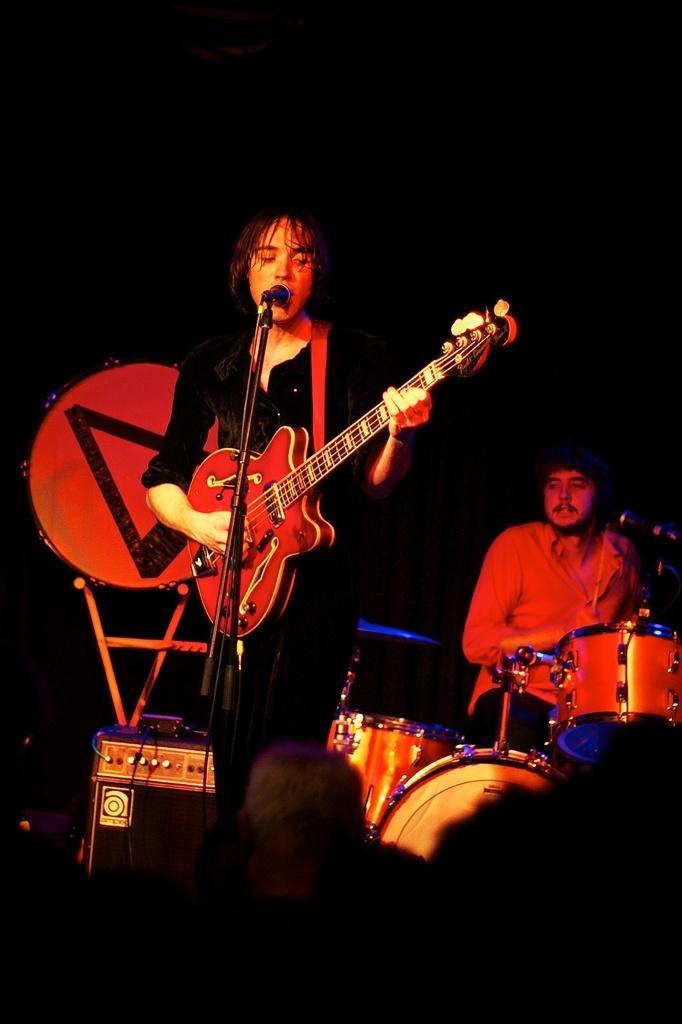Please provide a concise description of this image. In the picture there are two persons in which one person is playing guitar and singing in a microphone in front of him another person is sitting and playing drums there are speakers near to the person. 